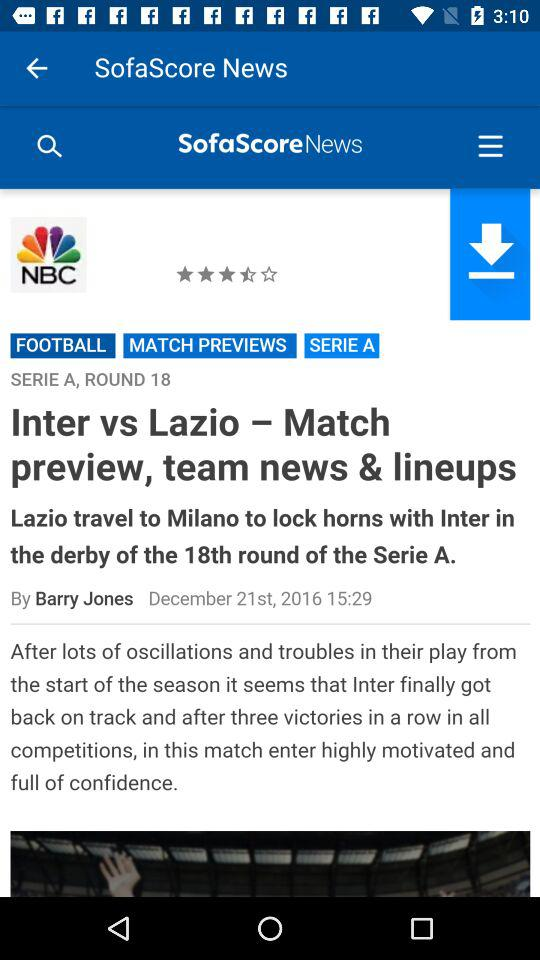What are the news headlines? The news headline is "Inter vs Lazio - Match preview, team news & lineups". 